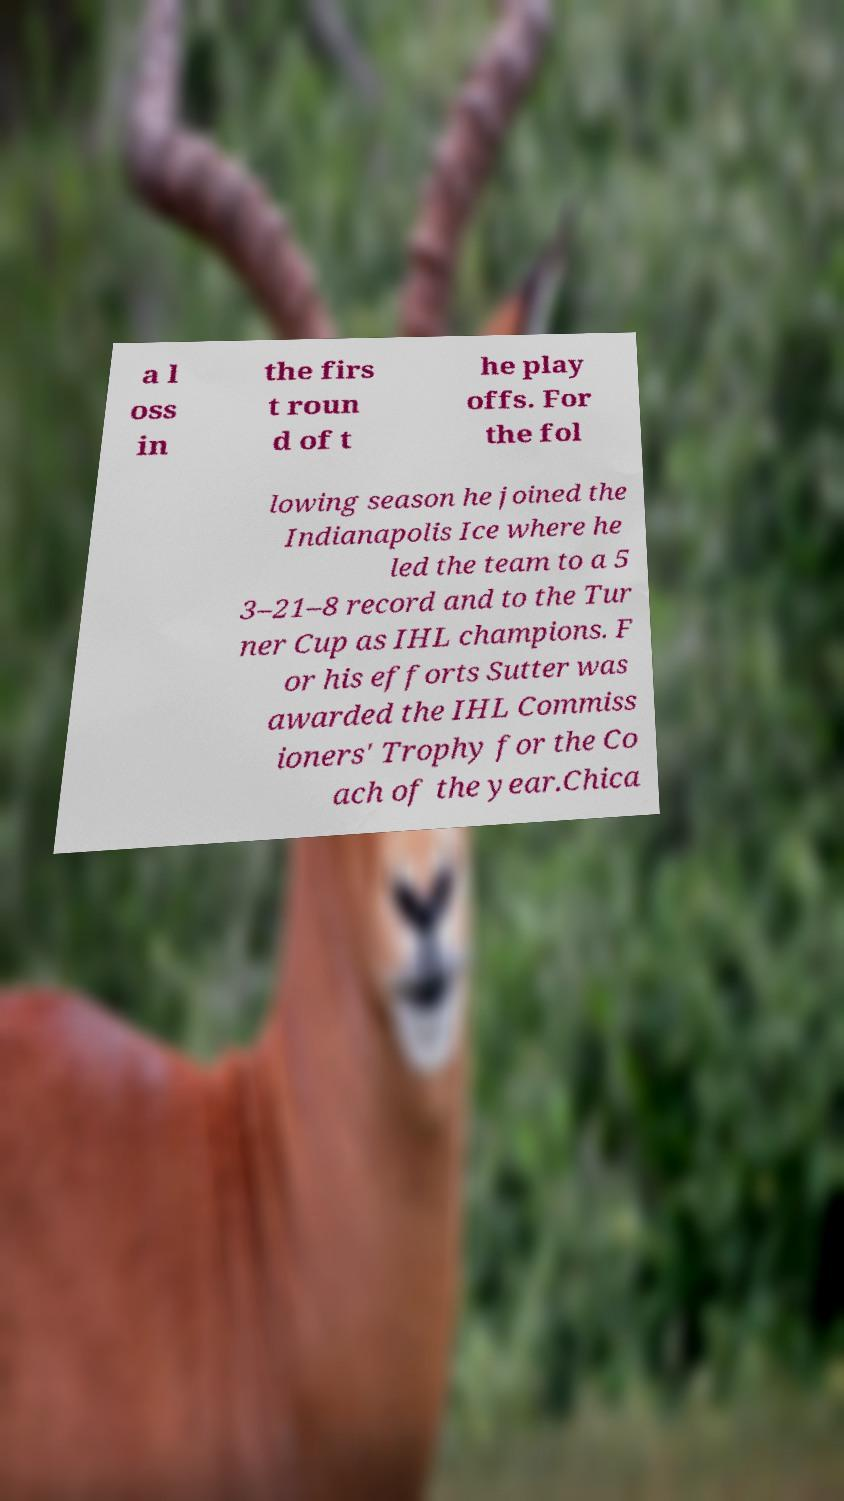Please identify and transcribe the text found in this image. a l oss in the firs t roun d of t he play offs. For the fol lowing season he joined the Indianapolis Ice where he led the team to a 5 3–21–8 record and to the Tur ner Cup as IHL champions. F or his efforts Sutter was awarded the IHL Commiss ioners' Trophy for the Co ach of the year.Chica 